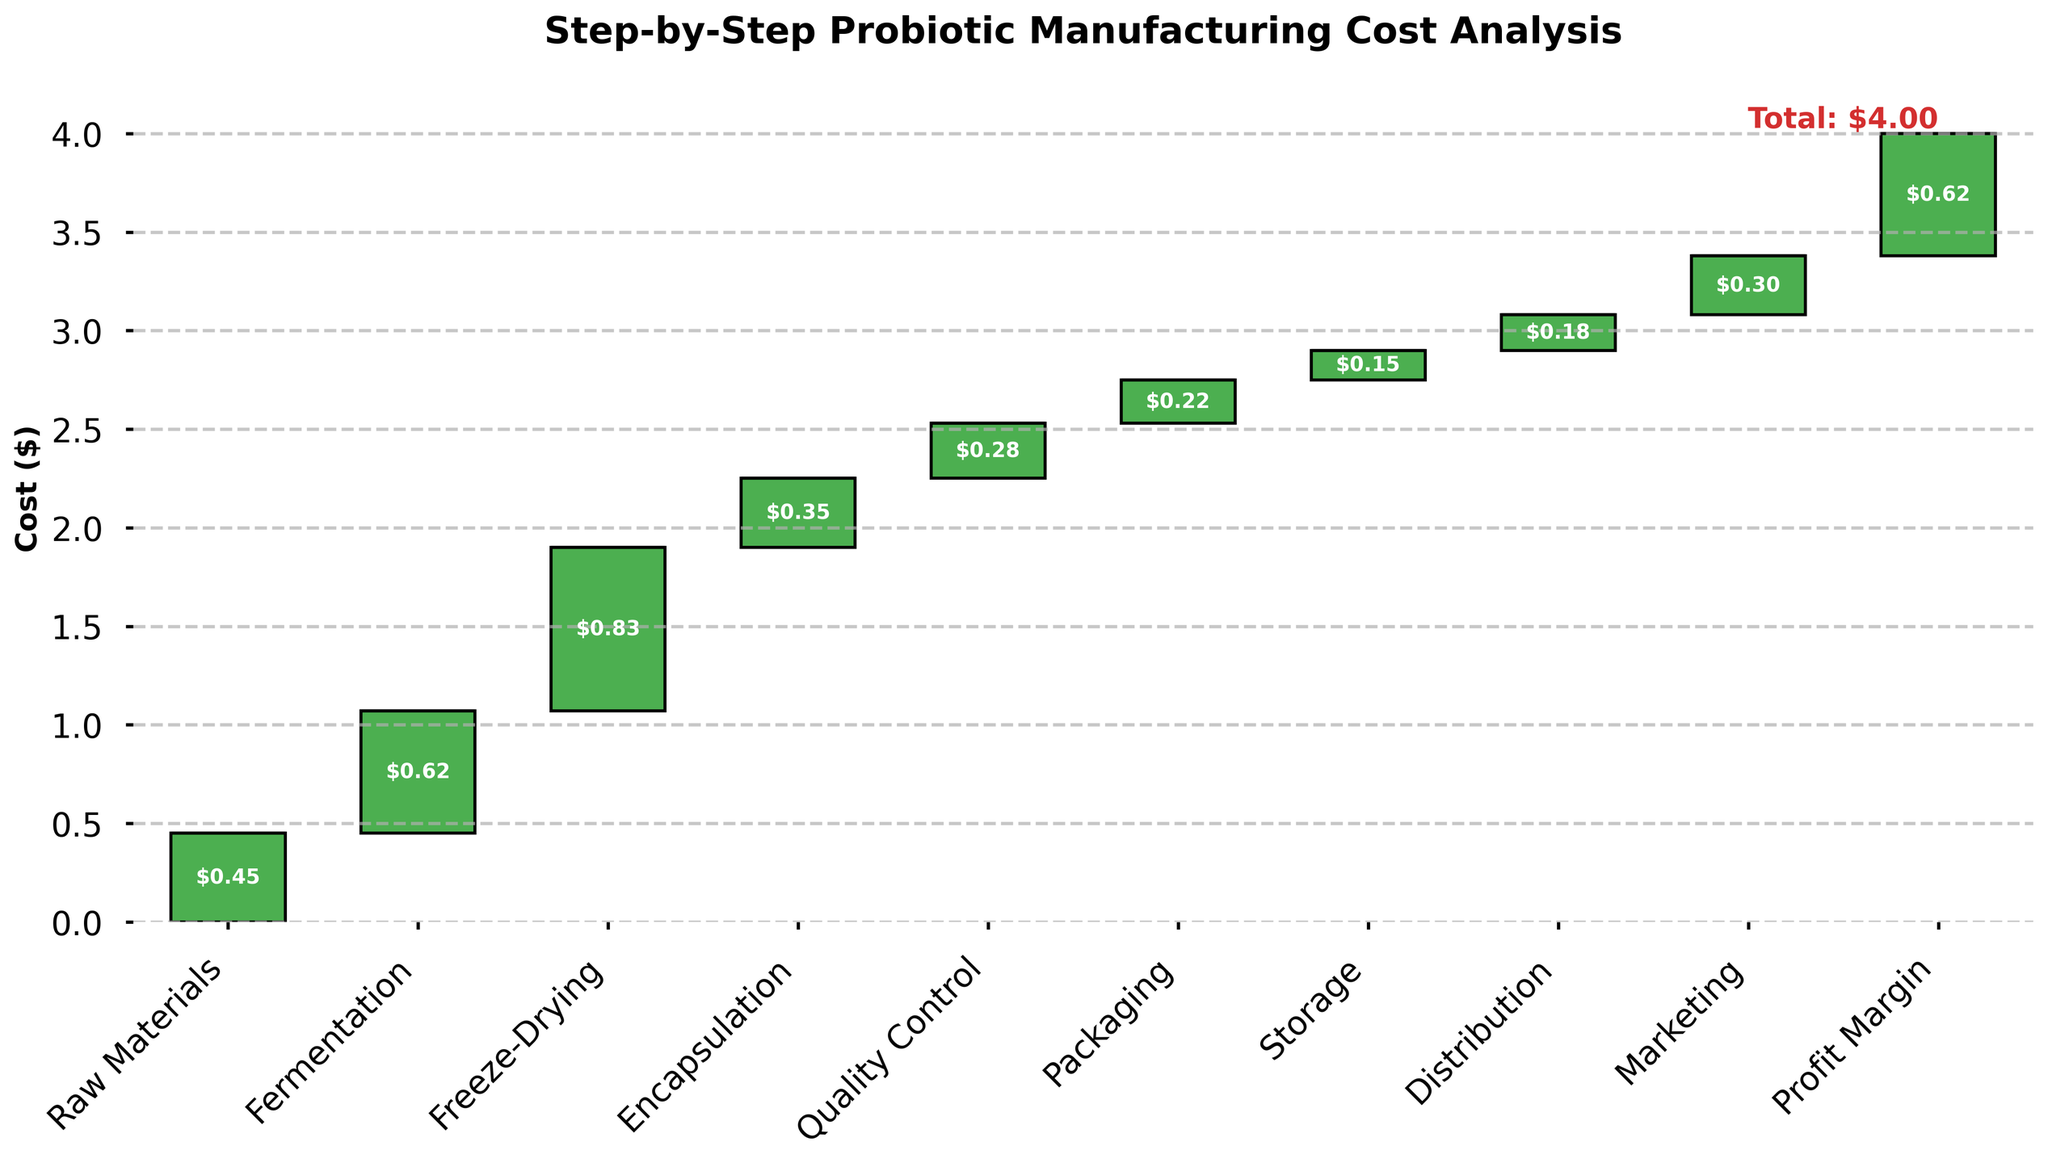What is the title of the chart? The title is usually the most prominent text at the top of the chart. In this case, it states the overall purpose or subject of the chart.
Answer: Step-by-Step Probiotic Manufacturing Cost Analysis How many cost categories are listed in the chart? You can count the number of distinct categories labeled on the x-axis below each bar. Each category stands for a step in the manufacturing process.
Answer: 10 Which manufacturing step has the highest associated cost? By comparing the heights of all the bars representing each step, the tallest bar indicates the step with the highest cost.
Answer: Freeze-Drying What is the cost associated with Quality Control? Looking at the height of the bar labeled 'Quality Control' and the value inside the bar, you can determine its cost.
Answer: $0.28 How does the cost of Distribution compare to Packaging? Compare the heights of the bars labeled 'Distribution' and 'Packaging'. Determine which is taller or if they are equal.
Answer: The cost of Distribution ($0.18) is less than Packaging ($0.22) What is the cumulative cost before Marketing? Sum the values of all steps up to and including Storage, but excluding Marketing. Verify with the cumulative sum at that point in the waterfall chart.
Answer: $4.00 - $0.30 = $3.70 What's the difference between the costs of Freeze-Drying and Encapsulation? Subtract the value of 'Encapsulation' from 'Freeze-Drying' to find the difference.
Answer: $0.83 - $0.35 = $0.48 What is the cumulative cost up to Fermentation? Add the costs of 'Raw Materials' and 'Fermentation' to get the cumulative value at that step.
Answer: $0.45 + $0.62 = $1.07 Which two steps combined are closest in value to Marketing? Determine which two steps combined have a sum nearest to the cost of 'Marketing'. For example, add the costs of potential pairs and find which sum is closest to $0.30.
Answer: Raw Materials ($0.45) and Storage ($0.15) What is the proportion of the Packaging cost relative to the total cost? Divide the Packaging cost by the total manufacturing cost and multiply by 100 to get the percentage.
Answer: ($0.22 / $4.00) * 100 = 5.5% 